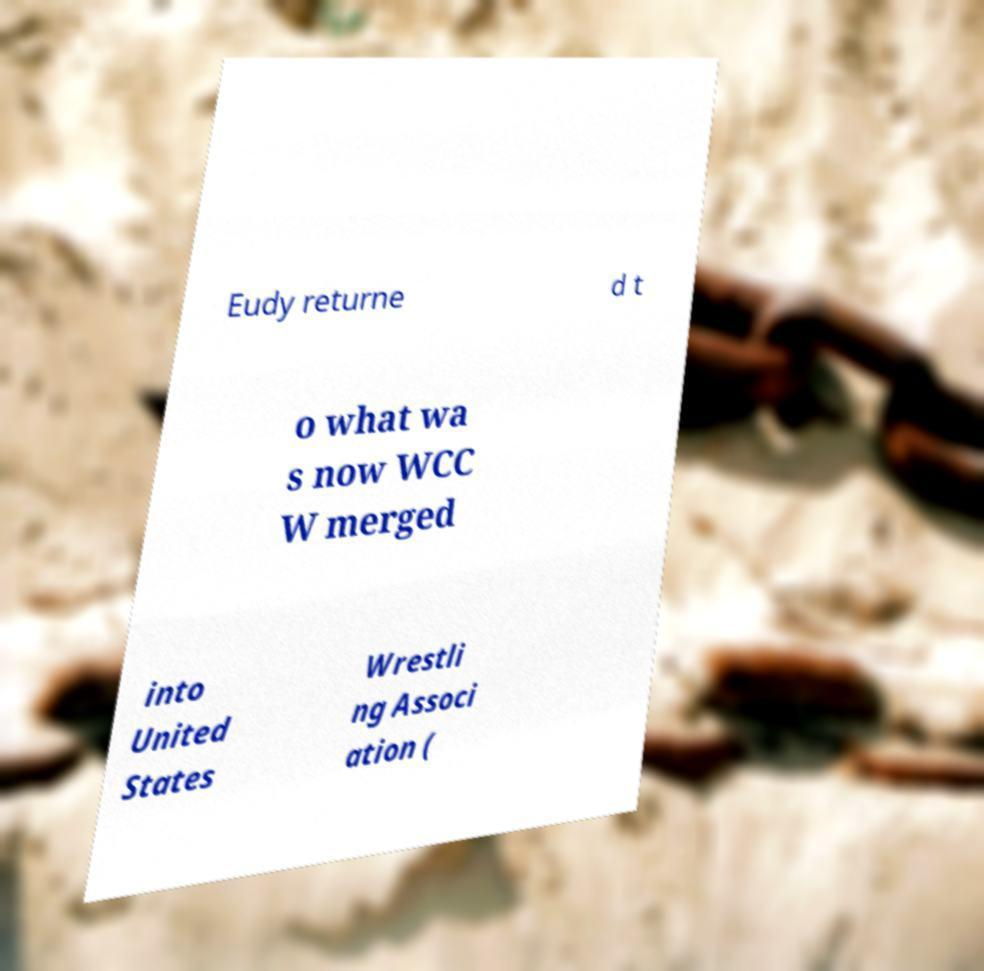Could you extract and type out the text from this image? Eudy returne d t o what wa s now WCC W merged into United States Wrestli ng Associ ation ( 